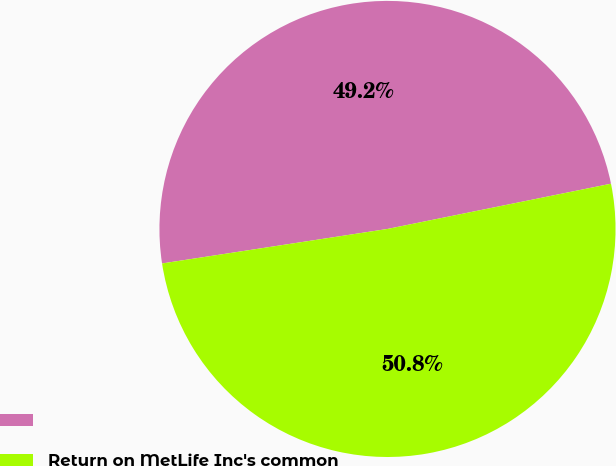Convert chart. <chart><loc_0><loc_0><loc_500><loc_500><pie_chart><ecel><fcel>Return on MetLife Inc's common<nl><fcel>49.24%<fcel>50.76%<nl></chart> 